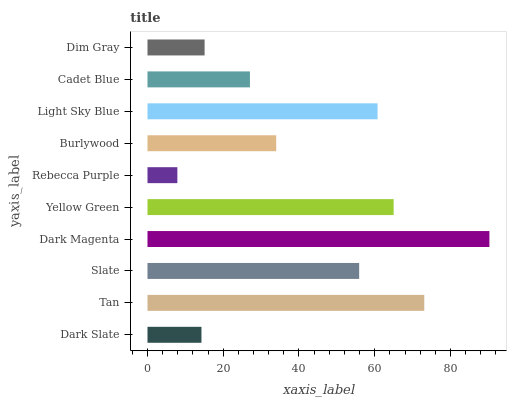Is Rebecca Purple the minimum?
Answer yes or no. Yes. Is Dark Magenta the maximum?
Answer yes or no. Yes. Is Tan the minimum?
Answer yes or no. No. Is Tan the maximum?
Answer yes or no. No. Is Tan greater than Dark Slate?
Answer yes or no. Yes. Is Dark Slate less than Tan?
Answer yes or no. Yes. Is Dark Slate greater than Tan?
Answer yes or no. No. Is Tan less than Dark Slate?
Answer yes or no. No. Is Slate the high median?
Answer yes or no. Yes. Is Burlywood the low median?
Answer yes or no. Yes. Is Tan the high median?
Answer yes or no. No. Is Cadet Blue the low median?
Answer yes or no. No. 